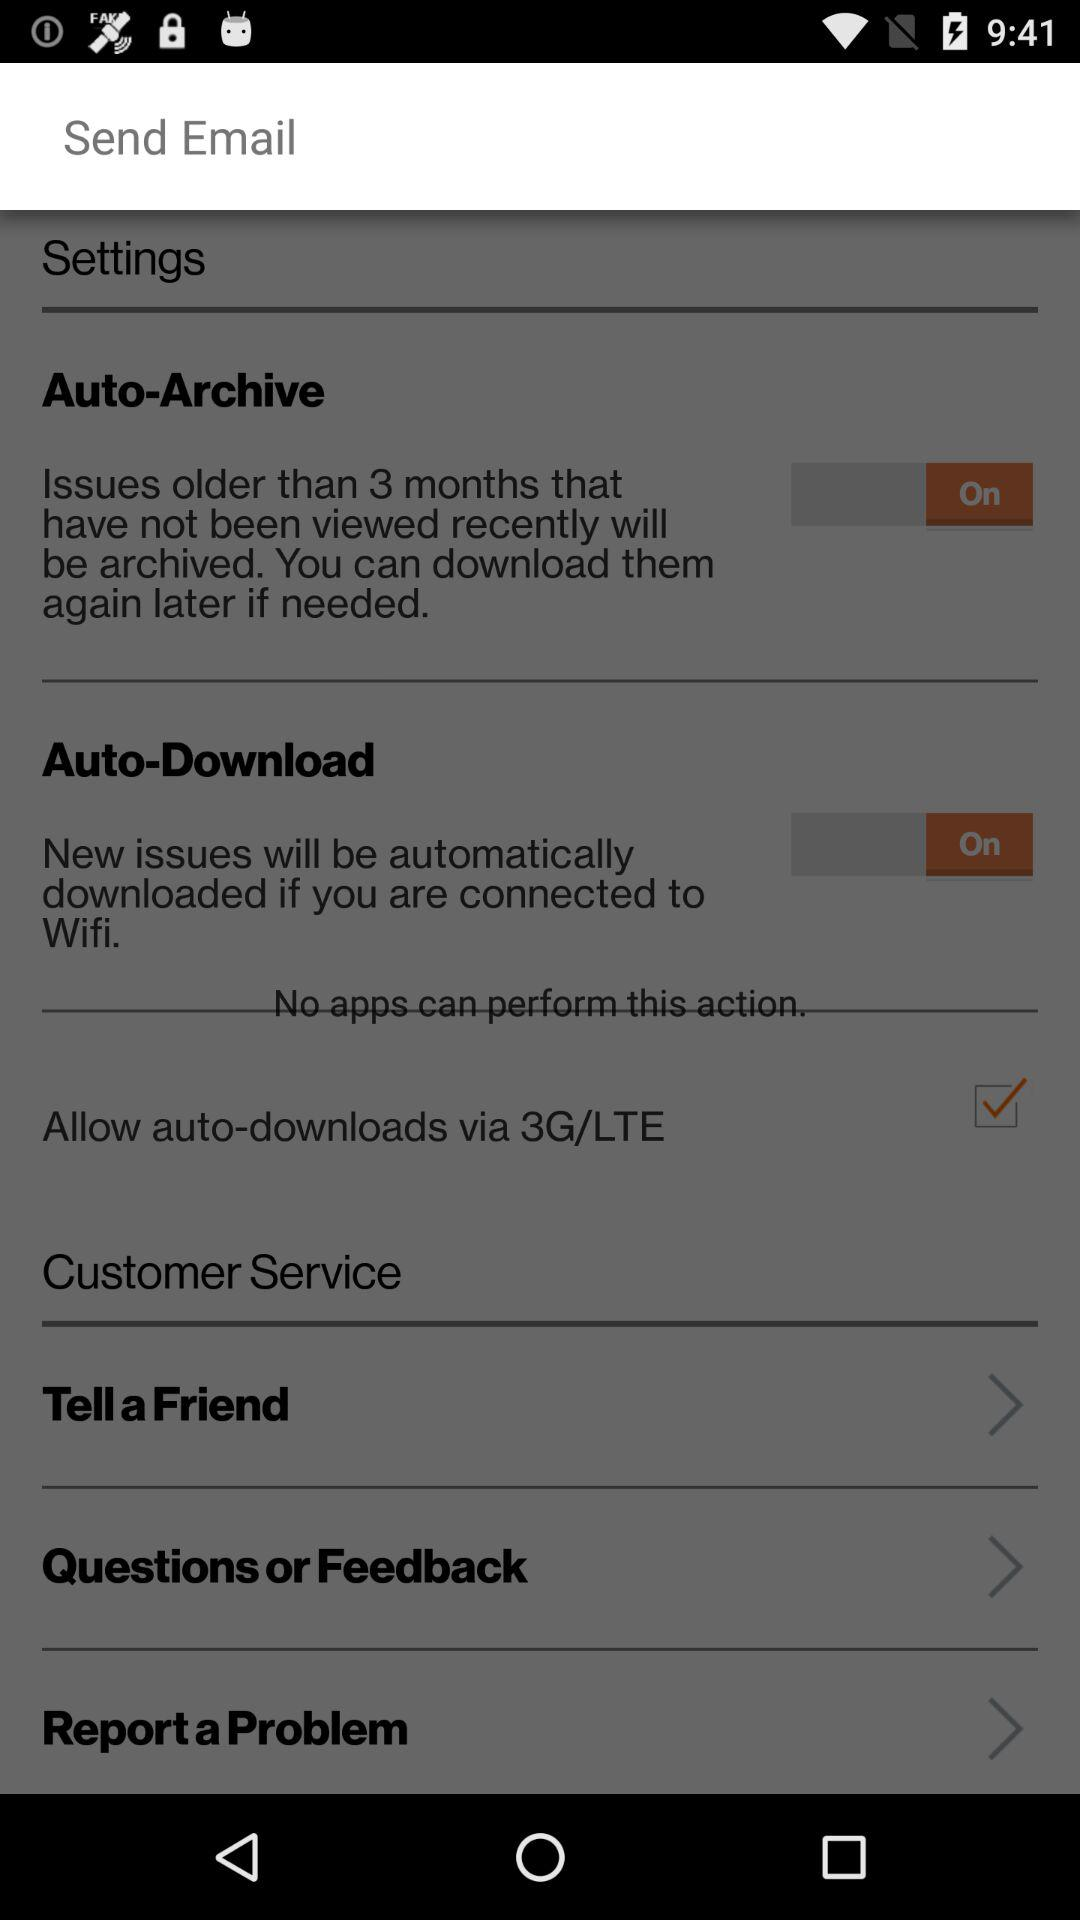What is the current status of the "Auto-Download" setting? The status is "on". 